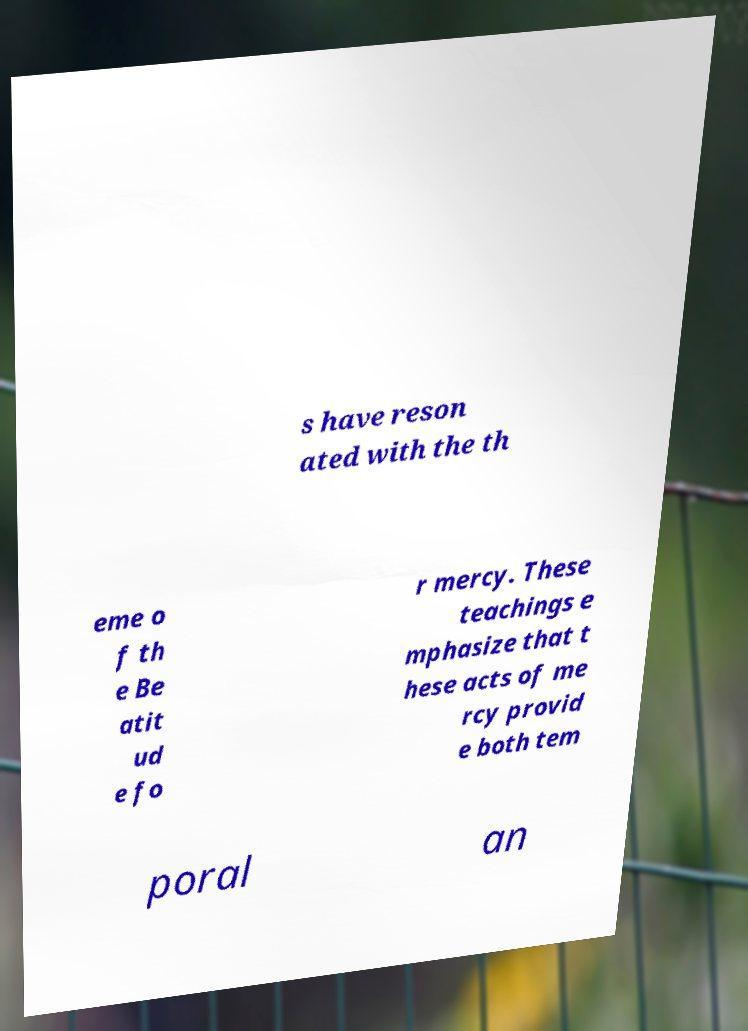I need the written content from this picture converted into text. Can you do that? s have reson ated with the th eme o f th e Be atit ud e fo r mercy. These teachings e mphasize that t hese acts of me rcy provid e both tem poral an 